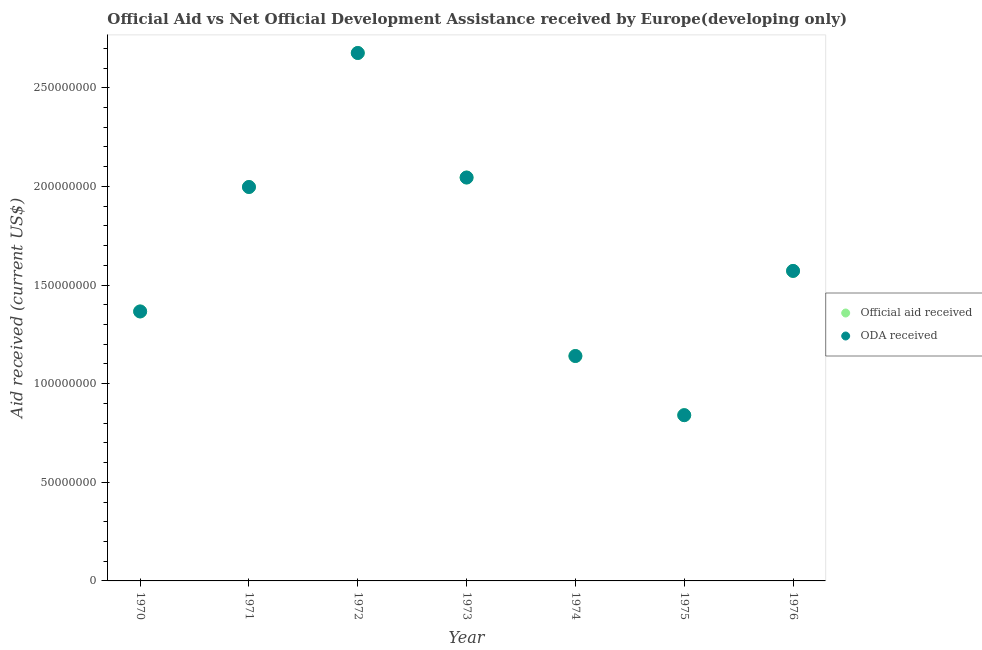How many different coloured dotlines are there?
Give a very brief answer. 2. What is the official aid received in 1970?
Provide a succinct answer. 1.37e+08. Across all years, what is the maximum oda received?
Your answer should be very brief. 2.68e+08. Across all years, what is the minimum oda received?
Make the answer very short. 8.40e+07. In which year was the oda received minimum?
Provide a succinct answer. 1975. What is the total official aid received in the graph?
Keep it short and to the point. 1.16e+09. What is the difference between the oda received in 1970 and that in 1973?
Provide a succinct answer. -6.79e+07. What is the difference between the official aid received in 1974 and the oda received in 1970?
Make the answer very short. -2.26e+07. What is the average oda received per year?
Offer a very short reply. 1.66e+08. What is the ratio of the oda received in 1971 to that in 1973?
Your response must be concise. 0.98. Is the oda received in 1971 less than that in 1975?
Give a very brief answer. No. Is the difference between the oda received in 1970 and 1975 greater than the difference between the official aid received in 1970 and 1975?
Offer a very short reply. No. What is the difference between the highest and the second highest official aid received?
Give a very brief answer. 6.31e+07. What is the difference between the highest and the lowest oda received?
Ensure brevity in your answer.  1.84e+08. In how many years, is the official aid received greater than the average official aid received taken over all years?
Offer a very short reply. 3. Is the oda received strictly less than the official aid received over the years?
Give a very brief answer. No. How many years are there in the graph?
Your answer should be very brief. 7. What is the difference between two consecutive major ticks on the Y-axis?
Your answer should be compact. 5.00e+07. Are the values on the major ticks of Y-axis written in scientific E-notation?
Provide a succinct answer. No. Does the graph contain any zero values?
Give a very brief answer. No. Where does the legend appear in the graph?
Make the answer very short. Center right. How many legend labels are there?
Your response must be concise. 2. How are the legend labels stacked?
Your response must be concise. Vertical. What is the title of the graph?
Keep it short and to the point. Official Aid vs Net Official Development Assistance received by Europe(developing only) . Does "Investments" appear as one of the legend labels in the graph?
Your answer should be very brief. No. What is the label or title of the X-axis?
Offer a very short reply. Year. What is the label or title of the Y-axis?
Make the answer very short. Aid received (current US$). What is the Aid received (current US$) of Official aid received in 1970?
Give a very brief answer. 1.37e+08. What is the Aid received (current US$) in ODA received in 1970?
Provide a succinct answer. 1.37e+08. What is the Aid received (current US$) in Official aid received in 1971?
Your response must be concise. 2.00e+08. What is the Aid received (current US$) of ODA received in 1971?
Offer a terse response. 2.00e+08. What is the Aid received (current US$) of Official aid received in 1972?
Your response must be concise. 2.68e+08. What is the Aid received (current US$) in ODA received in 1972?
Your answer should be compact. 2.68e+08. What is the Aid received (current US$) in Official aid received in 1973?
Keep it short and to the point. 2.05e+08. What is the Aid received (current US$) of ODA received in 1973?
Offer a terse response. 2.05e+08. What is the Aid received (current US$) in Official aid received in 1974?
Make the answer very short. 1.14e+08. What is the Aid received (current US$) in ODA received in 1974?
Offer a very short reply. 1.14e+08. What is the Aid received (current US$) of Official aid received in 1975?
Give a very brief answer. 8.40e+07. What is the Aid received (current US$) in ODA received in 1975?
Keep it short and to the point. 8.40e+07. What is the Aid received (current US$) of Official aid received in 1976?
Make the answer very short. 1.57e+08. What is the Aid received (current US$) of ODA received in 1976?
Keep it short and to the point. 1.57e+08. Across all years, what is the maximum Aid received (current US$) of Official aid received?
Your answer should be very brief. 2.68e+08. Across all years, what is the maximum Aid received (current US$) in ODA received?
Give a very brief answer. 2.68e+08. Across all years, what is the minimum Aid received (current US$) of Official aid received?
Your answer should be very brief. 8.40e+07. Across all years, what is the minimum Aid received (current US$) in ODA received?
Provide a short and direct response. 8.40e+07. What is the total Aid received (current US$) in Official aid received in the graph?
Give a very brief answer. 1.16e+09. What is the total Aid received (current US$) in ODA received in the graph?
Offer a very short reply. 1.16e+09. What is the difference between the Aid received (current US$) in Official aid received in 1970 and that in 1971?
Give a very brief answer. -6.31e+07. What is the difference between the Aid received (current US$) of ODA received in 1970 and that in 1971?
Offer a terse response. -6.31e+07. What is the difference between the Aid received (current US$) in Official aid received in 1970 and that in 1972?
Provide a short and direct response. -1.31e+08. What is the difference between the Aid received (current US$) of ODA received in 1970 and that in 1972?
Provide a short and direct response. -1.31e+08. What is the difference between the Aid received (current US$) in Official aid received in 1970 and that in 1973?
Make the answer very short. -6.79e+07. What is the difference between the Aid received (current US$) of ODA received in 1970 and that in 1973?
Ensure brevity in your answer.  -6.79e+07. What is the difference between the Aid received (current US$) in Official aid received in 1970 and that in 1974?
Provide a short and direct response. 2.26e+07. What is the difference between the Aid received (current US$) of ODA received in 1970 and that in 1974?
Your answer should be very brief. 2.26e+07. What is the difference between the Aid received (current US$) in Official aid received in 1970 and that in 1975?
Provide a succinct answer. 5.26e+07. What is the difference between the Aid received (current US$) in ODA received in 1970 and that in 1975?
Your response must be concise. 5.26e+07. What is the difference between the Aid received (current US$) of Official aid received in 1970 and that in 1976?
Your answer should be compact. -2.06e+07. What is the difference between the Aid received (current US$) in ODA received in 1970 and that in 1976?
Make the answer very short. -2.06e+07. What is the difference between the Aid received (current US$) of Official aid received in 1971 and that in 1972?
Offer a terse response. -6.79e+07. What is the difference between the Aid received (current US$) in ODA received in 1971 and that in 1972?
Offer a terse response. -6.79e+07. What is the difference between the Aid received (current US$) of Official aid received in 1971 and that in 1973?
Offer a very short reply. -4.80e+06. What is the difference between the Aid received (current US$) in ODA received in 1971 and that in 1973?
Make the answer very short. -4.80e+06. What is the difference between the Aid received (current US$) in Official aid received in 1971 and that in 1974?
Your answer should be compact. 8.57e+07. What is the difference between the Aid received (current US$) in ODA received in 1971 and that in 1974?
Give a very brief answer. 8.57e+07. What is the difference between the Aid received (current US$) of Official aid received in 1971 and that in 1975?
Make the answer very short. 1.16e+08. What is the difference between the Aid received (current US$) of ODA received in 1971 and that in 1975?
Ensure brevity in your answer.  1.16e+08. What is the difference between the Aid received (current US$) in Official aid received in 1971 and that in 1976?
Offer a very short reply. 4.26e+07. What is the difference between the Aid received (current US$) in ODA received in 1971 and that in 1976?
Give a very brief answer. 4.26e+07. What is the difference between the Aid received (current US$) of Official aid received in 1972 and that in 1973?
Make the answer very short. 6.31e+07. What is the difference between the Aid received (current US$) of ODA received in 1972 and that in 1973?
Provide a short and direct response. 6.31e+07. What is the difference between the Aid received (current US$) of Official aid received in 1972 and that in 1974?
Your answer should be very brief. 1.54e+08. What is the difference between the Aid received (current US$) of ODA received in 1972 and that in 1974?
Offer a terse response. 1.54e+08. What is the difference between the Aid received (current US$) in Official aid received in 1972 and that in 1975?
Offer a very short reply. 1.84e+08. What is the difference between the Aid received (current US$) of ODA received in 1972 and that in 1975?
Your answer should be compact. 1.84e+08. What is the difference between the Aid received (current US$) of Official aid received in 1972 and that in 1976?
Your response must be concise. 1.10e+08. What is the difference between the Aid received (current US$) of ODA received in 1972 and that in 1976?
Offer a very short reply. 1.10e+08. What is the difference between the Aid received (current US$) in Official aid received in 1973 and that in 1974?
Your answer should be compact. 9.05e+07. What is the difference between the Aid received (current US$) of ODA received in 1973 and that in 1974?
Offer a terse response. 9.05e+07. What is the difference between the Aid received (current US$) in Official aid received in 1973 and that in 1975?
Give a very brief answer. 1.20e+08. What is the difference between the Aid received (current US$) in ODA received in 1973 and that in 1975?
Your answer should be compact. 1.20e+08. What is the difference between the Aid received (current US$) in Official aid received in 1973 and that in 1976?
Make the answer very short. 4.74e+07. What is the difference between the Aid received (current US$) of ODA received in 1973 and that in 1976?
Offer a terse response. 4.74e+07. What is the difference between the Aid received (current US$) in Official aid received in 1974 and that in 1975?
Your answer should be very brief. 3.00e+07. What is the difference between the Aid received (current US$) of ODA received in 1974 and that in 1975?
Your answer should be compact. 3.00e+07. What is the difference between the Aid received (current US$) in Official aid received in 1974 and that in 1976?
Offer a very short reply. -4.31e+07. What is the difference between the Aid received (current US$) of ODA received in 1974 and that in 1976?
Give a very brief answer. -4.31e+07. What is the difference between the Aid received (current US$) in Official aid received in 1975 and that in 1976?
Your response must be concise. -7.31e+07. What is the difference between the Aid received (current US$) in ODA received in 1975 and that in 1976?
Offer a very short reply. -7.31e+07. What is the difference between the Aid received (current US$) in Official aid received in 1970 and the Aid received (current US$) in ODA received in 1971?
Your response must be concise. -6.31e+07. What is the difference between the Aid received (current US$) in Official aid received in 1970 and the Aid received (current US$) in ODA received in 1972?
Provide a short and direct response. -1.31e+08. What is the difference between the Aid received (current US$) in Official aid received in 1970 and the Aid received (current US$) in ODA received in 1973?
Give a very brief answer. -6.79e+07. What is the difference between the Aid received (current US$) of Official aid received in 1970 and the Aid received (current US$) of ODA received in 1974?
Make the answer very short. 2.26e+07. What is the difference between the Aid received (current US$) in Official aid received in 1970 and the Aid received (current US$) in ODA received in 1975?
Give a very brief answer. 5.26e+07. What is the difference between the Aid received (current US$) in Official aid received in 1970 and the Aid received (current US$) in ODA received in 1976?
Provide a short and direct response. -2.06e+07. What is the difference between the Aid received (current US$) of Official aid received in 1971 and the Aid received (current US$) of ODA received in 1972?
Your answer should be very brief. -6.79e+07. What is the difference between the Aid received (current US$) in Official aid received in 1971 and the Aid received (current US$) in ODA received in 1973?
Keep it short and to the point. -4.80e+06. What is the difference between the Aid received (current US$) of Official aid received in 1971 and the Aid received (current US$) of ODA received in 1974?
Your response must be concise. 8.57e+07. What is the difference between the Aid received (current US$) of Official aid received in 1971 and the Aid received (current US$) of ODA received in 1975?
Keep it short and to the point. 1.16e+08. What is the difference between the Aid received (current US$) of Official aid received in 1971 and the Aid received (current US$) of ODA received in 1976?
Provide a short and direct response. 4.26e+07. What is the difference between the Aid received (current US$) of Official aid received in 1972 and the Aid received (current US$) of ODA received in 1973?
Ensure brevity in your answer.  6.31e+07. What is the difference between the Aid received (current US$) in Official aid received in 1972 and the Aid received (current US$) in ODA received in 1974?
Your answer should be very brief. 1.54e+08. What is the difference between the Aid received (current US$) in Official aid received in 1972 and the Aid received (current US$) in ODA received in 1975?
Your answer should be very brief. 1.84e+08. What is the difference between the Aid received (current US$) of Official aid received in 1972 and the Aid received (current US$) of ODA received in 1976?
Keep it short and to the point. 1.10e+08. What is the difference between the Aid received (current US$) in Official aid received in 1973 and the Aid received (current US$) in ODA received in 1974?
Offer a very short reply. 9.05e+07. What is the difference between the Aid received (current US$) in Official aid received in 1973 and the Aid received (current US$) in ODA received in 1975?
Ensure brevity in your answer.  1.20e+08. What is the difference between the Aid received (current US$) in Official aid received in 1973 and the Aid received (current US$) in ODA received in 1976?
Your answer should be very brief. 4.74e+07. What is the difference between the Aid received (current US$) in Official aid received in 1974 and the Aid received (current US$) in ODA received in 1975?
Your response must be concise. 3.00e+07. What is the difference between the Aid received (current US$) of Official aid received in 1974 and the Aid received (current US$) of ODA received in 1976?
Give a very brief answer. -4.31e+07. What is the difference between the Aid received (current US$) of Official aid received in 1975 and the Aid received (current US$) of ODA received in 1976?
Ensure brevity in your answer.  -7.31e+07. What is the average Aid received (current US$) in Official aid received per year?
Your response must be concise. 1.66e+08. What is the average Aid received (current US$) in ODA received per year?
Make the answer very short. 1.66e+08. In the year 1972, what is the difference between the Aid received (current US$) in Official aid received and Aid received (current US$) in ODA received?
Ensure brevity in your answer.  0. In the year 1973, what is the difference between the Aid received (current US$) in Official aid received and Aid received (current US$) in ODA received?
Offer a very short reply. 0. In the year 1974, what is the difference between the Aid received (current US$) of Official aid received and Aid received (current US$) of ODA received?
Offer a very short reply. 0. In the year 1975, what is the difference between the Aid received (current US$) in Official aid received and Aid received (current US$) in ODA received?
Keep it short and to the point. 0. In the year 1976, what is the difference between the Aid received (current US$) of Official aid received and Aid received (current US$) of ODA received?
Your answer should be compact. 0. What is the ratio of the Aid received (current US$) in Official aid received in 1970 to that in 1971?
Your answer should be compact. 0.68. What is the ratio of the Aid received (current US$) of ODA received in 1970 to that in 1971?
Your answer should be compact. 0.68. What is the ratio of the Aid received (current US$) of Official aid received in 1970 to that in 1972?
Your response must be concise. 0.51. What is the ratio of the Aid received (current US$) in ODA received in 1970 to that in 1972?
Provide a succinct answer. 0.51. What is the ratio of the Aid received (current US$) in Official aid received in 1970 to that in 1973?
Your answer should be compact. 0.67. What is the ratio of the Aid received (current US$) in ODA received in 1970 to that in 1973?
Ensure brevity in your answer.  0.67. What is the ratio of the Aid received (current US$) of Official aid received in 1970 to that in 1974?
Ensure brevity in your answer.  1.2. What is the ratio of the Aid received (current US$) in ODA received in 1970 to that in 1974?
Keep it short and to the point. 1.2. What is the ratio of the Aid received (current US$) in Official aid received in 1970 to that in 1975?
Provide a succinct answer. 1.63. What is the ratio of the Aid received (current US$) of ODA received in 1970 to that in 1975?
Ensure brevity in your answer.  1.63. What is the ratio of the Aid received (current US$) of Official aid received in 1970 to that in 1976?
Offer a very short reply. 0.87. What is the ratio of the Aid received (current US$) in ODA received in 1970 to that in 1976?
Offer a very short reply. 0.87. What is the ratio of the Aid received (current US$) of Official aid received in 1971 to that in 1972?
Offer a terse response. 0.75. What is the ratio of the Aid received (current US$) in ODA received in 1971 to that in 1972?
Give a very brief answer. 0.75. What is the ratio of the Aid received (current US$) of Official aid received in 1971 to that in 1973?
Make the answer very short. 0.98. What is the ratio of the Aid received (current US$) in ODA received in 1971 to that in 1973?
Provide a succinct answer. 0.98. What is the ratio of the Aid received (current US$) in Official aid received in 1971 to that in 1974?
Your answer should be compact. 1.75. What is the ratio of the Aid received (current US$) in ODA received in 1971 to that in 1974?
Provide a succinct answer. 1.75. What is the ratio of the Aid received (current US$) in Official aid received in 1971 to that in 1975?
Your answer should be compact. 2.38. What is the ratio of the Aid received (current US$) in ODA received in 1971 to that in 1975?
Your response must be concise. 2.38. What is the ratio of the Aid received (current US$) in Official aid received in 1971 to that in 1976?
Provide a short and direct response. 1.27. What is the ratio of the Aid received (current US$) in ODA received in 1971 to that in 1976?
Offer a terse response. 1.27. What is the ratio of the Aid received (current US$) of Official aid received in 1972 to that in 1973?
Your response must be concise. 1.31. What is the ratio of the Aid received (current US$) in ODA received in 1972 to that in 1973?
Your answer should be very brief. 1.31. What is the ratio of the Aid received (current US$) in Official aid received in 1972 to that in 1974?
Provide a succinct answer. 2.35. What is the ratio of the Aid received (current US$) of ODA received in 1972 to that in 1974?
Keep it short and to the point. 2.35. What is the ratio of the Aid received (current US$) in Official aid received in 1972 to that in 1975?
Ensure brevity in your answer.  3.18. What is the ratio of the Aid received (current US$) in ODA received in 1972 to that in 1975?
Give a very brief answer. 3.18. What is the ratio of the Aid received (current US$) of Official aid received in 1972 to that in 1976?
Ensure brevity in your answer.  1.7. What is the ratio of the Aid received (current US$) of ODA received in 1972 to that in 1976?
Offer a terse response. 1.7. What is the ratio of the Aid received (current US$) in Official aid received in 1973 to that in 1974?
Provide a short and direct response. 1.79. What is the ratio of the Aid received (current US$) in ODA received in 1973 to that in 1974?
Give a very brief answer. 1.79. What is the ratio of the Aid received (current US$) in Official aid received in 1973 to that in 1975?
Provide a short and direct response. 2.43. What is the ratio of the Aid received (current US$) of ODA received in 1973 to that in 1975?
Keep it short and to the point. 2.43. What is the ratio of the Aid received (current US$) of Official aid received in 1973 to that in 1976?
Your answer should be compact. 1.3. What is the ratio of the Aid received (current US$) of ODA received in 1973 to that in 1976?
Offer a terse response. 1.3. What is the ratio of the Aid received (current US$) in Official aid received in 1974 to that in 1975?
Offer a very short reply. 1.36. What is the ratio of the Aid received (current US$) in ODA received in 1974 to that in 1975?
Provide a succinct answer. 1.36. What is the ratio of the Aid received (current US$) in Official aid received in 1974 to that in 1976?
Make the answer very short. 0.73. What is the ratio of the Aid received (current US$) of ODA received in 1974 to that in 1976?
Ensure brevity in your answer.  0.73. What is the ratio of the Aid received (current US$) in Official aid received in 1975 to that in 1976?
Offer a terse response. 0.53. What is the ratio of the Aid received (current US$) of ODA received in 1975 to that in 1976?
Provide a succinct answer. 0.53. What is the difference between the highest and the second highest Aid received (current US$) of Official aid received?
Keep it short and to the point. 6.31e+07. What is the difference between the highest and the second highest Aid received (current US$) in ODA received?
Ensure brevity in your answer.  6.31e+07. What is the difference between the highest and the lowest Aid received (current US$) of Official aid received?
Offer a terse response. 1.84e+08. What is the difference between the highest and the lowest Aid received (current US$) of ODA received?
Make the answer very short. 1.84e+08. 